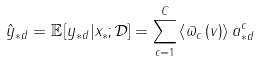<formula> <loc_0><loc_0><loc_500><loc_500>\hat { y } _ { * d } = \mathbb { E } \left [ y _ { * d } | x _ { * } ; \mathcal { D } \right ] = \sum _ { c = 1 } ^ { C } \left \langle \varpi _ { c } \left ( v \right ) \right \rangle a _ { * d } ^ { c }</formula> 